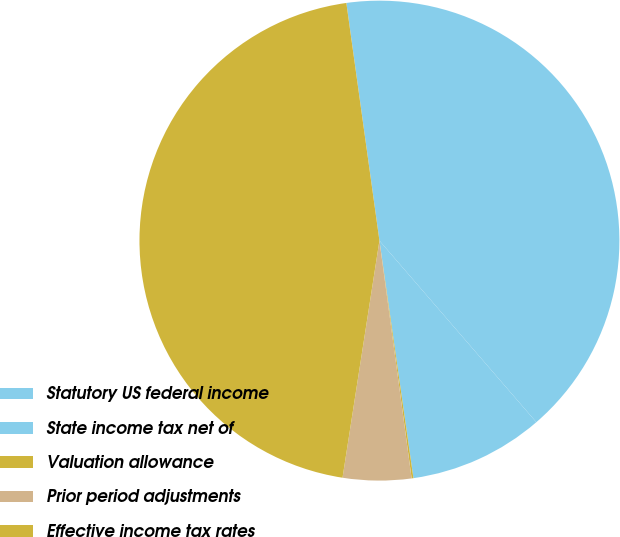Convert chart to OTSL. <chart><loc_0><loc_0><loc_500><loc_500><pie_chart><fcel>Statutory US federal income<fcel>State income tax net of<fcel>Valuation allowance<fcel>Prior period adjustments<fcel>Effective income tax rates<nl><fcel>40.86%<fcel>9.08%<fcel>0.12%<fcel>4.6%<fcel>45.34%<nl></chart> 